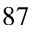<formula> <loc_0><loc_0><loc_500><loc_500>^ { 8 7 }</formula> 